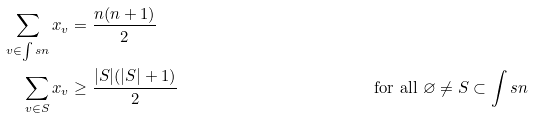Convert formula to latex. <formula><loc_0><loc_0><loc_500><loc_500>\sum _ { v \in \int s { n } } x _ { v } & = \frac { n ( n + 1 ) } { 2 } & & \\ \sum _ { v \in S } x _ { v } & \geq \frac { | S | ( | S | + 1 ) } { 2 } & & \text { for all } \varnothing \neq S \subset \int s { n }</formula> 